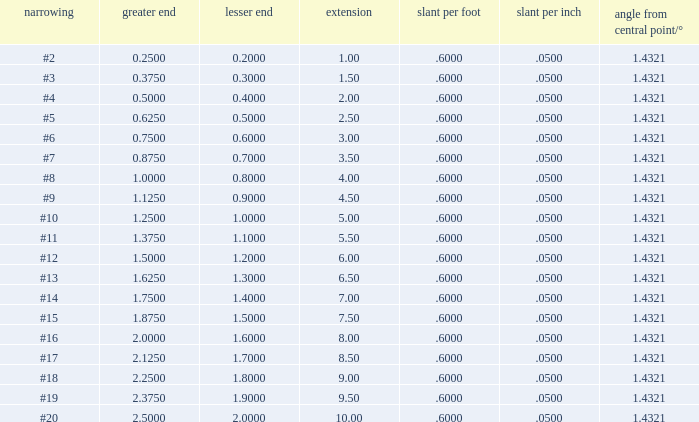Which Large end has a Taper/ft smaller than 0.6000000000000001? 19.0. 